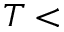Convert formula to latex. <formula><loc_0><loc_0><loc_500><loc_500>T <</formula> 